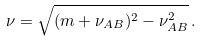<formula> <loc_0><loc_0><loc_500><loc_500>\nu = \sqrt { ( m + \nu _ { A B } ) ^ { 2 } - \nu _ { A B } ^ { 2 } } \, .</formula> 